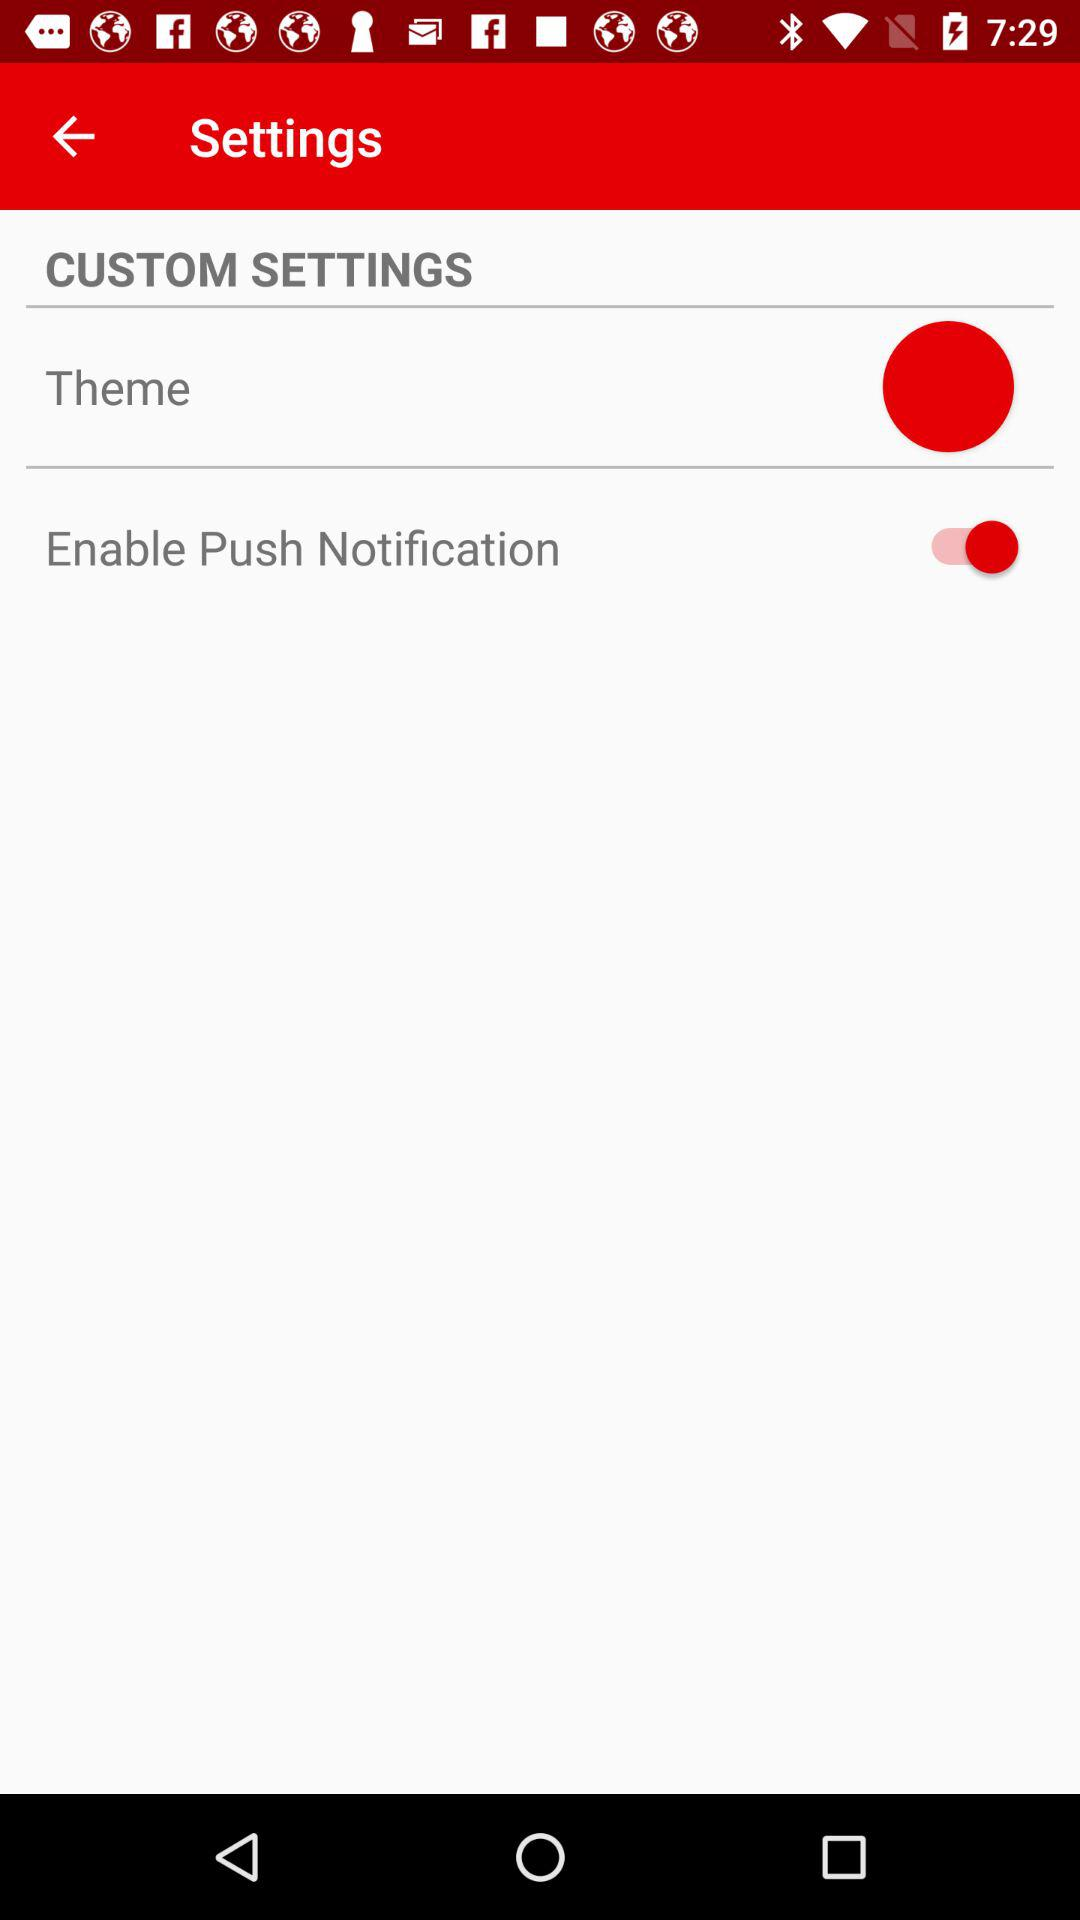What's the "Enable Push Notification" status? "Enable Push Notification" is turned on. 